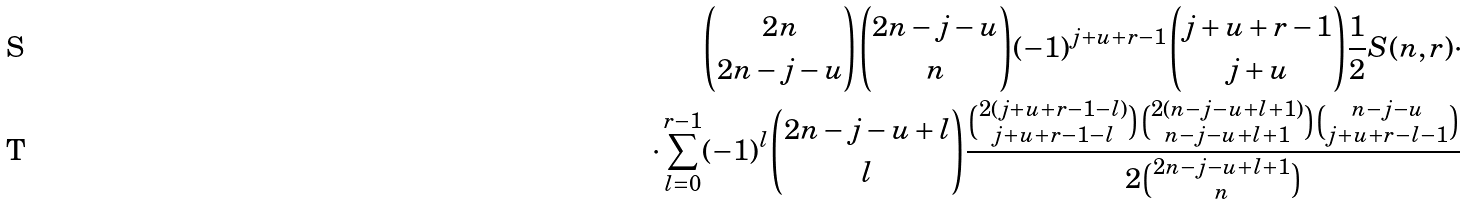Convert formula to latex. <formula><loc_0><loc_0><loc_500><loc_500>\binom { 2 n } { 2 n - j - u } \binom { 2 n - j - u } { n } ( - 1 ) ^ { j + u + r - 1 } \binom { j + u + r - 1 } { j + u } \frac { 1 } { 2 } S ( n , r ) \cdot \\ \cdot \sum _ { l = 0 } ^ { r - 1 } ( - 1 ) ^ { l } \binom { 2 n - j - u + l } { l } \frac { \binom { 2 ( j + u + r - 1 - l ) } { j + u + r - 1 - l } \binom { 2 ( n - j - u + l + 1 ) } { n - j - u + l + 1 } \binom { n - j - u } { j + u + r - l - 1 } } { 2 \binom { 2 n - j - u + l + 1 } { n } }</formula> 